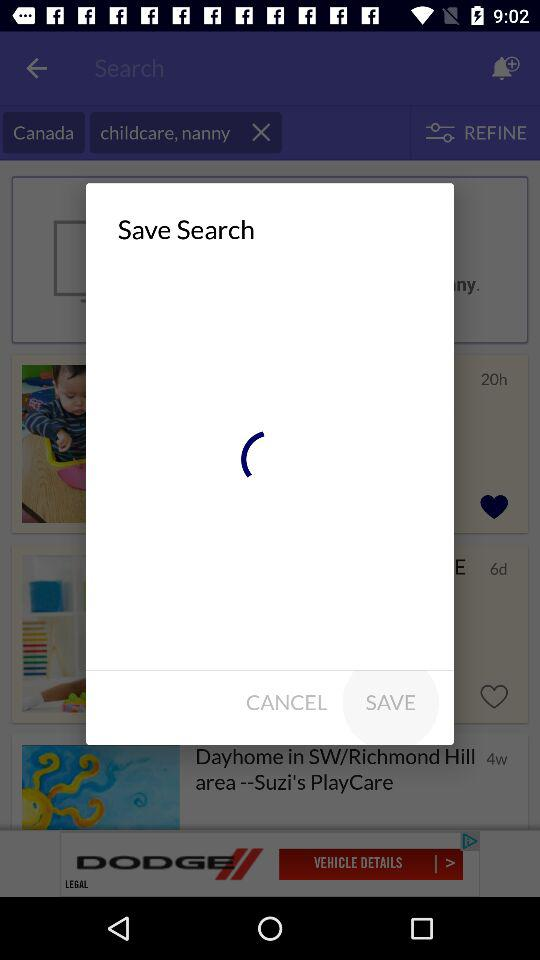What's the number of "All Ads"? The number is 6,779,857. 